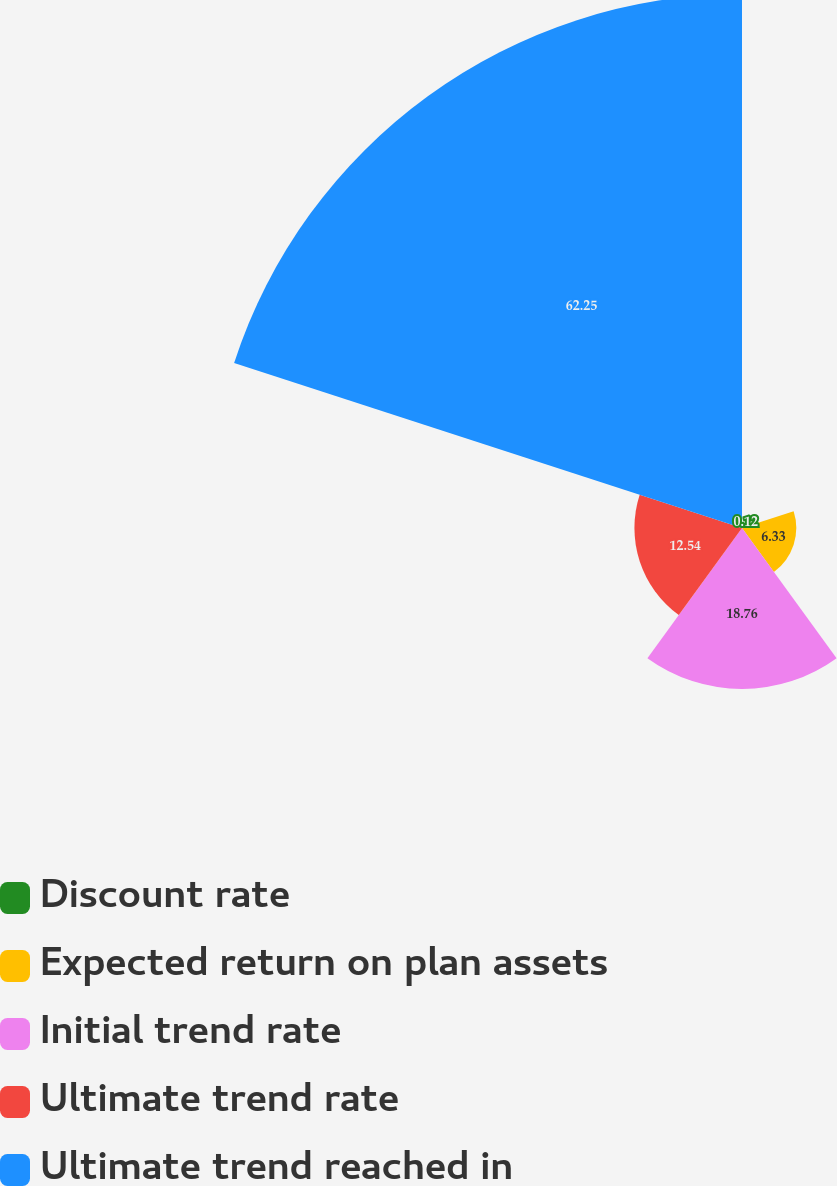Convert chart. <chart><loc_0><loc_0><loc_500><loc_500><pie_chart><fcel>Discount rate<fcel>Expected return on plan assets<fcel>Initial trend rate<fcel>Ultimate trend rate<fcel>Ultimate trend reached in<nl><fcel>0.12%<fcel>6.33%<fcel>18.76%<fcel>12.54%<fcel>62.25%<nl></chart> 